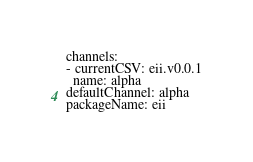<code> <loc_0><loc_0><loc_500><loc_500><_YAML_>channels:
- currentCSV: eii.v0.0.1
  name: alpha
defaultChannel: alpha
packageName: eii
</code> 